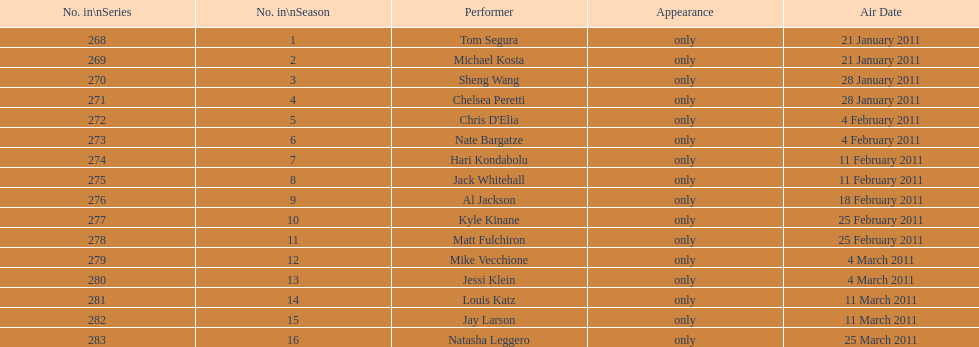Over how many weeks did season 15 of comedy central presents extend? 9. 